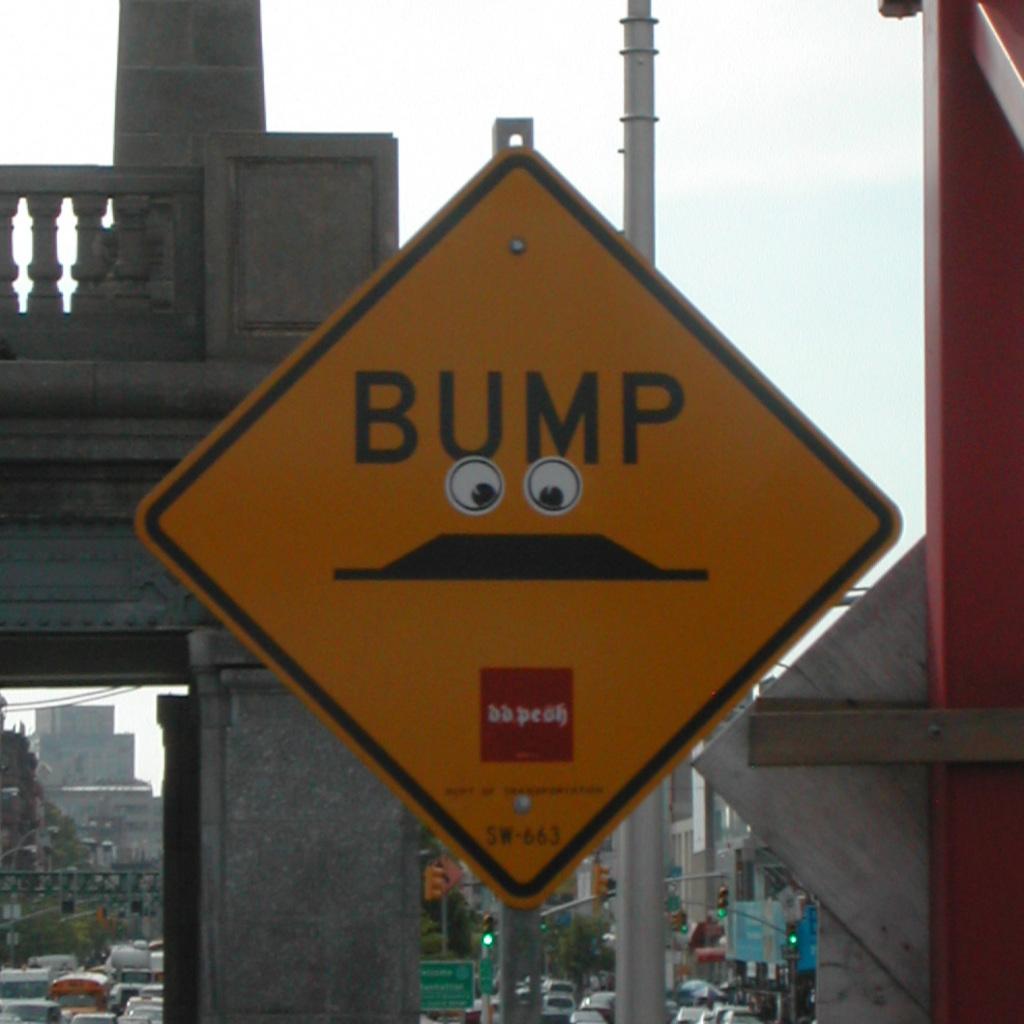What is the sign warning for?
Provide a short and direct response. Bump. What are the numbers at the bottom of the sign?
Offer a terse response. 663. 